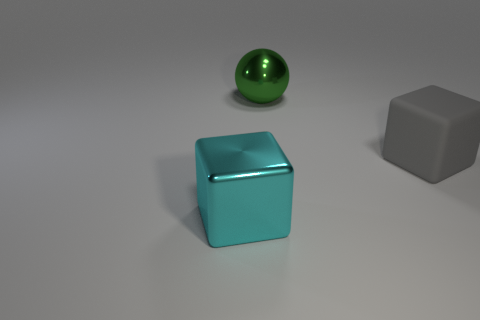Add 3 large metal cubes. How many objects exist? 6 Subtract all spheres. How many objects are left? 2 Subtract all tiny gray rubber cylinders. Subtract all blocks. How many objects are left? 1 Add 3 large blocks. How many large blocks are left? 5 Add 2 big brown blocks. How many big brown blocks exist? 2 Subtract 0 green cylinders. How many objects are left? 3 